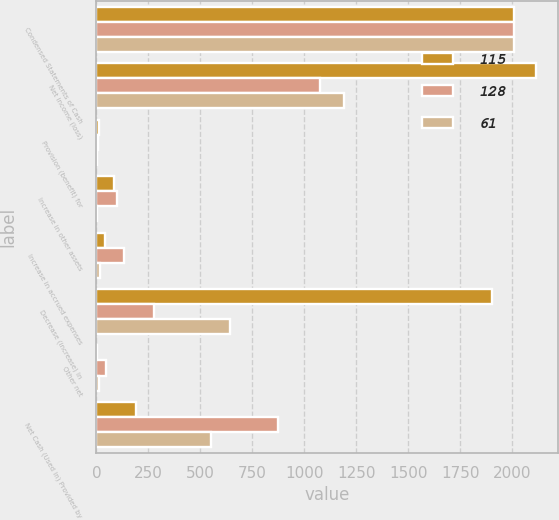<chart> <loc_0><loc_0><loc_500><loc_500><stacked_bar_chart><ecel><fcel>Condensed Statements of Cash<fcel>Net income (loss)<fcel>Provision (benefit) for<fcel>Increase in other assets<fcel>Increase in accrued expenses<fcel>Decrease (increase) in<fcel>Other net<fcel>Net Cash (Used in) Provided by<nl><fcel>115<fcel>2008<fcel>2113<fcel>11<fcel>85<fcel>40<fcel>1903<fcel>5<fcel>192<nl><fcel>128<fcel>2007<fcel>1076<fcel>7<fcel>98<fcel>132<fcel>276<fcel>46<fcel>873<nl><fcel>61<fcel>2006<fcel>1188<fcel>1<fcel>1<fcel>17<fcel>642<fcel>14<fcel>549<nl></chart> 